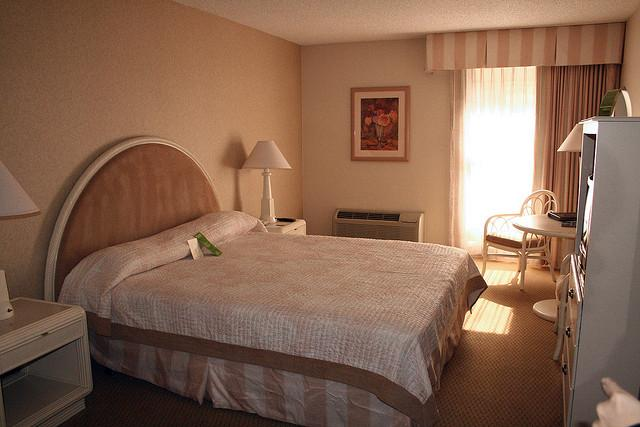What type of establishment is known to put notecards on beds like this? hotel 